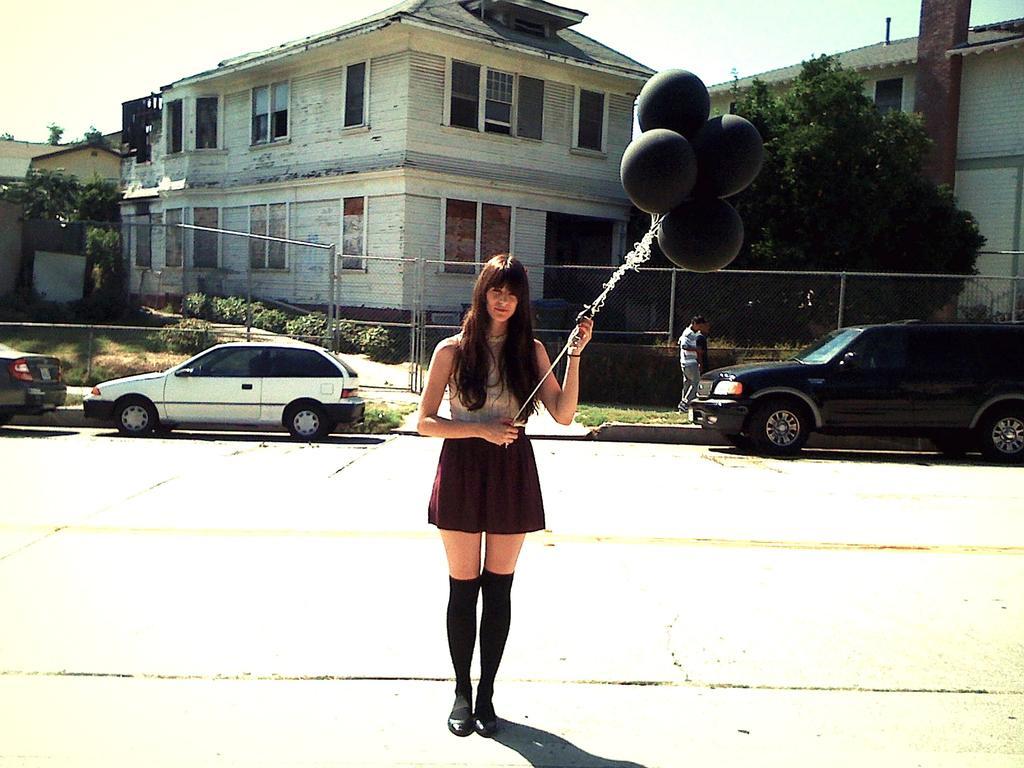In one or two sentences, can you explain what this image depicts? In this image we can see a few people, one woman is holding balloons, there are cars on the road, there are plants, trees, there are houses, windows, fencing, also we can see the sky. 